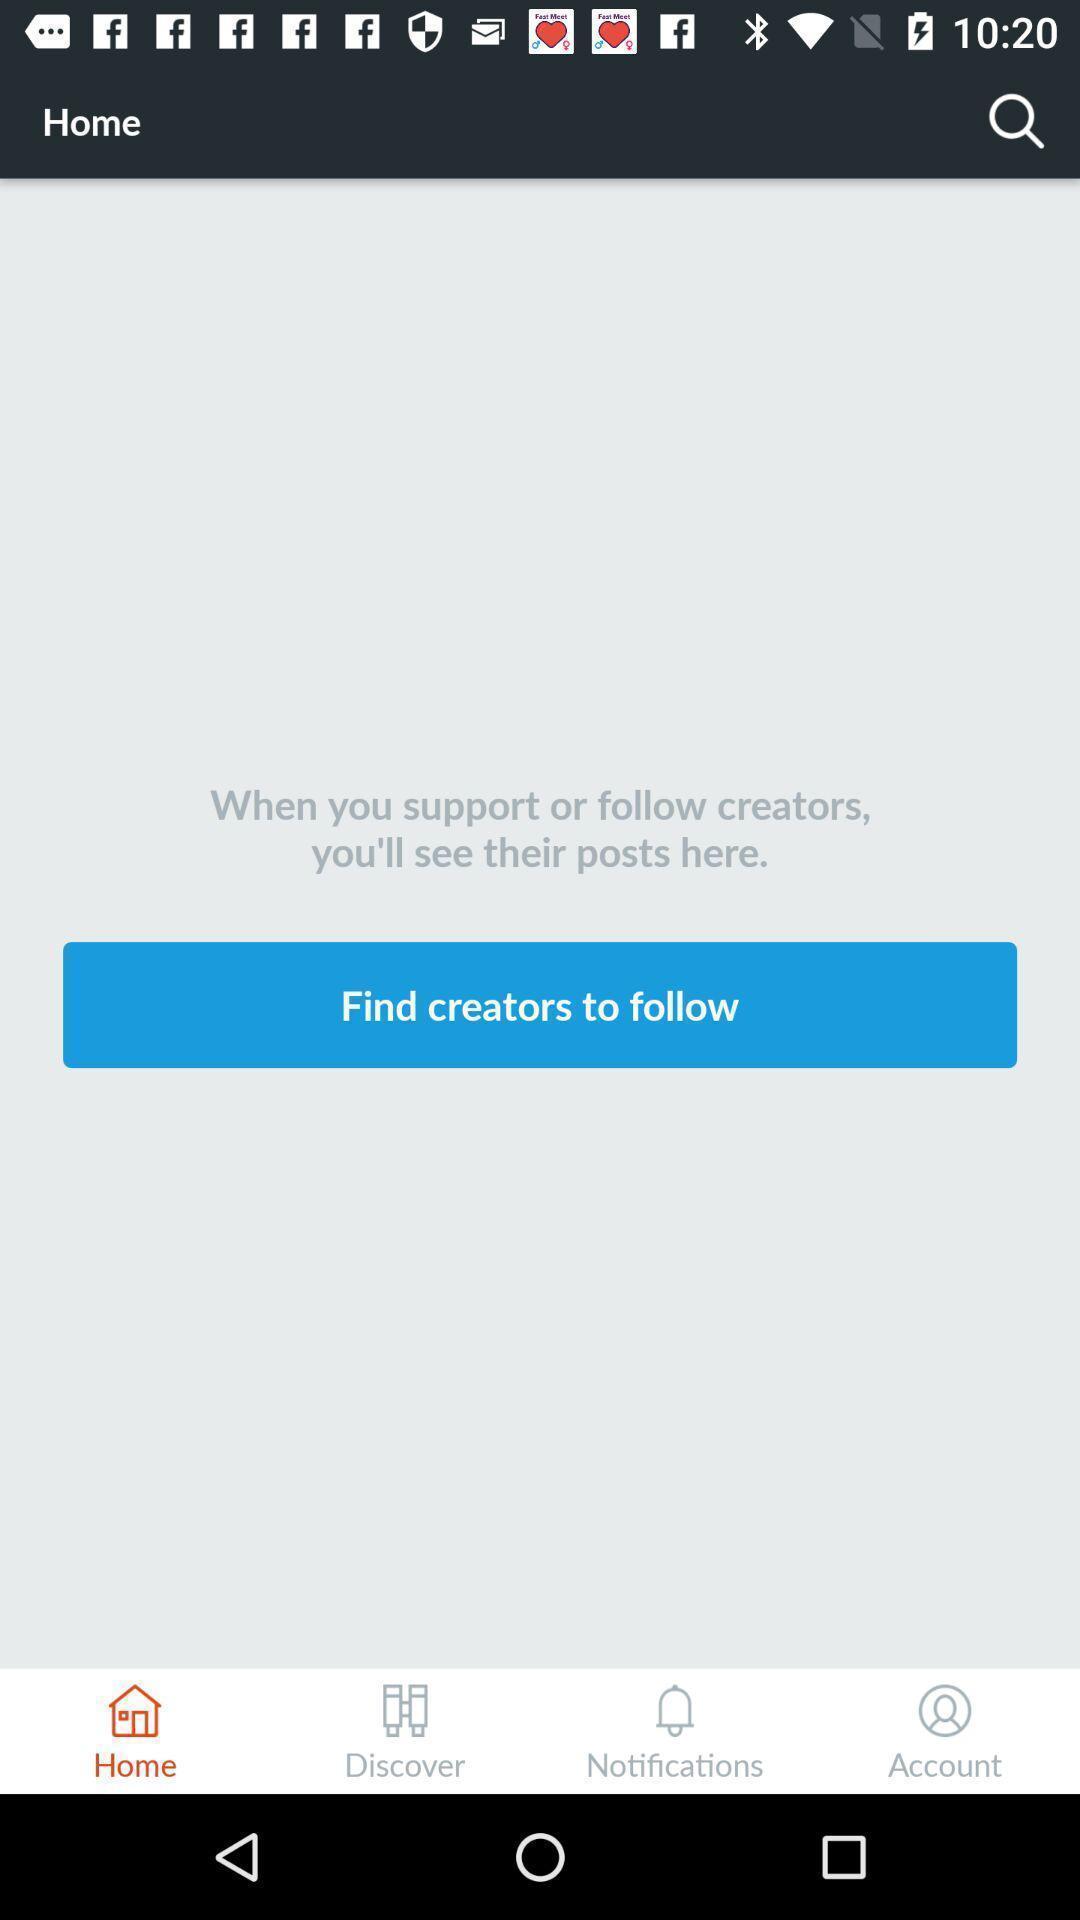Tell me about the visual elements in this screen capture. Screen shows home page. 